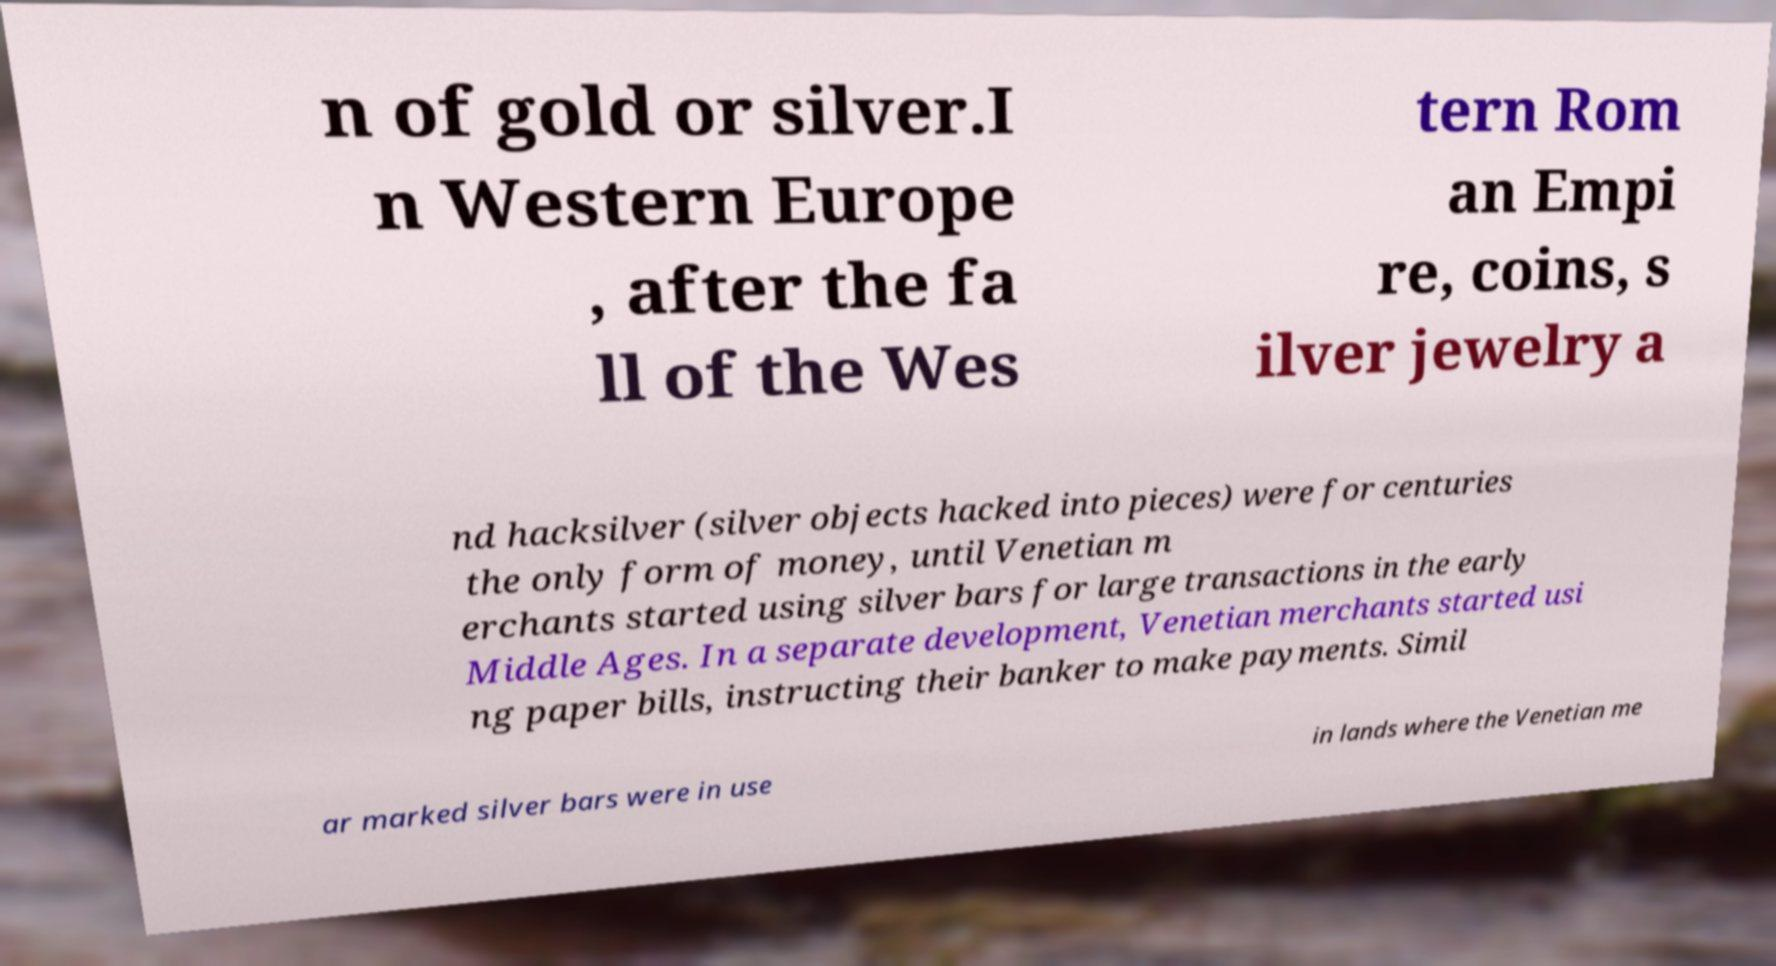Please identify and transcribe the text found in this image. n of gold or silver.I n Western Europe , after the fa ll of the Wes tern Rom an Empi re, coins, s ilver jewelry a nd hacksilver (silver objects hacked into pieces) were for centuries the only form of money, until Venetian m erchants started using silver bars for large transactions in the early Middle Ages. In a separate development, Venetian merchants started usi ng paper bills, instructing their banker to make payments. Simil ar marked silver bars were in use in lands where the Venetian me 